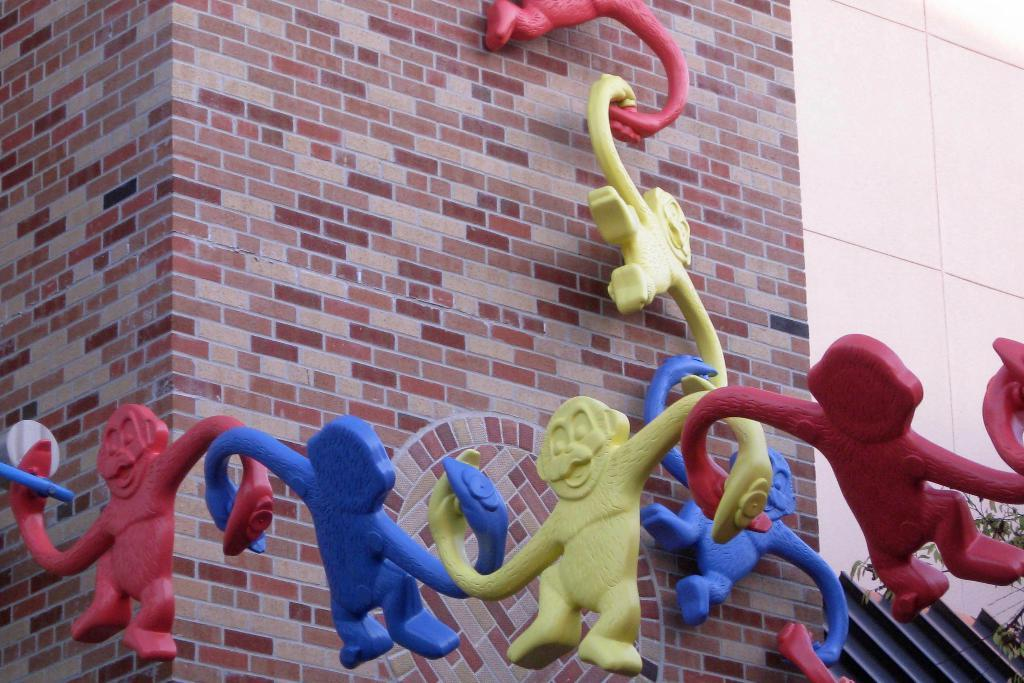What type of sculptures are in the image? There are monkey sculptures in the image. What colors are the monkey sculptures? The monkey sculptures are red, blue, and green in color. What can be seen in the background of the image? There is a brick wall in the background of the image. Who is the manager of the yard in the image? There is no yard or manager present in the image; it features monkey sculptures and a brick wall. 